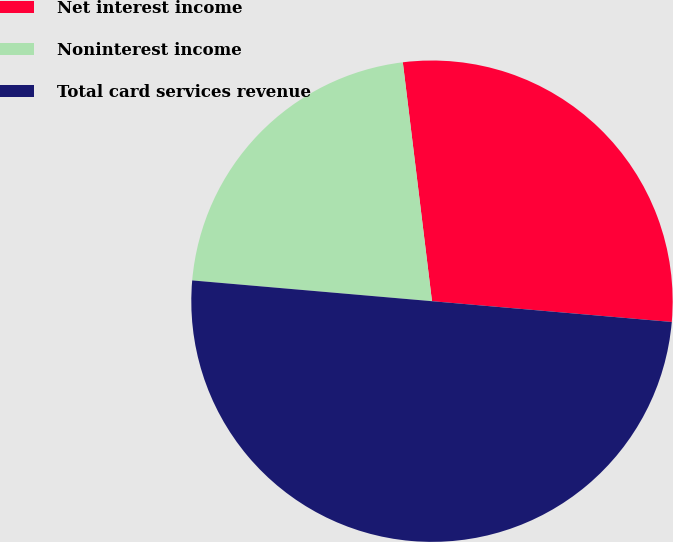<chart> <loc_0><loc_0><loc_500><loc_500><pie_chart><fcel>Net interest income<fcel>Noninterest income<fcel>Total card services revenue<nl><fcel>28.31%<fcel>21.69%<fcel>50.0%<nl></chart> 